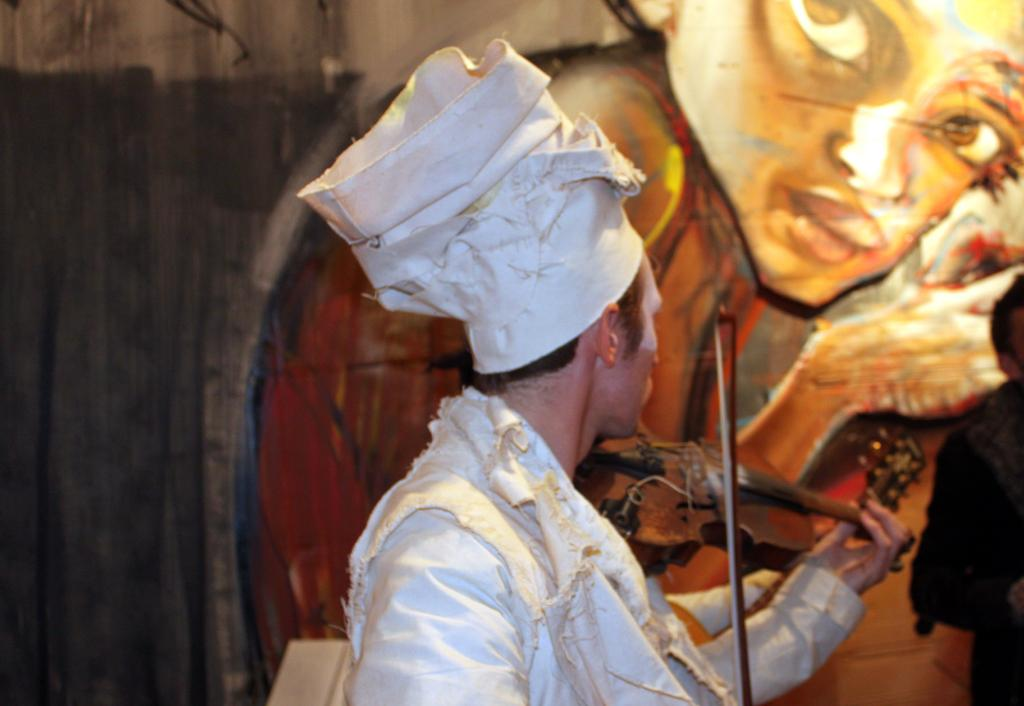What is the man in the image doing? The man is playing a violin in the image. Are there any other people present in the image? Yes, there are people in the image. What can be seen in the background of the image? There is wall art in the background of the image. Reasoning: Let' Let's think step by step in order to produce the conversation. We start by identifying the main subject of the image, which is the man playing the violin. Then, we expand the conversation to include the presence of other people and the wall art in the background. Each question is designed to elicit a specific detail about the image that is known from the provided facts. Absurd Question/Answer: What type of nerve can be seen in the image? There is no nerve present in the image; it features a man playing a violin, people, and wall art. What type of wheel can be seen in the image? There is no wheel present in the image; it features a man playing a violin, people, and wall art. 